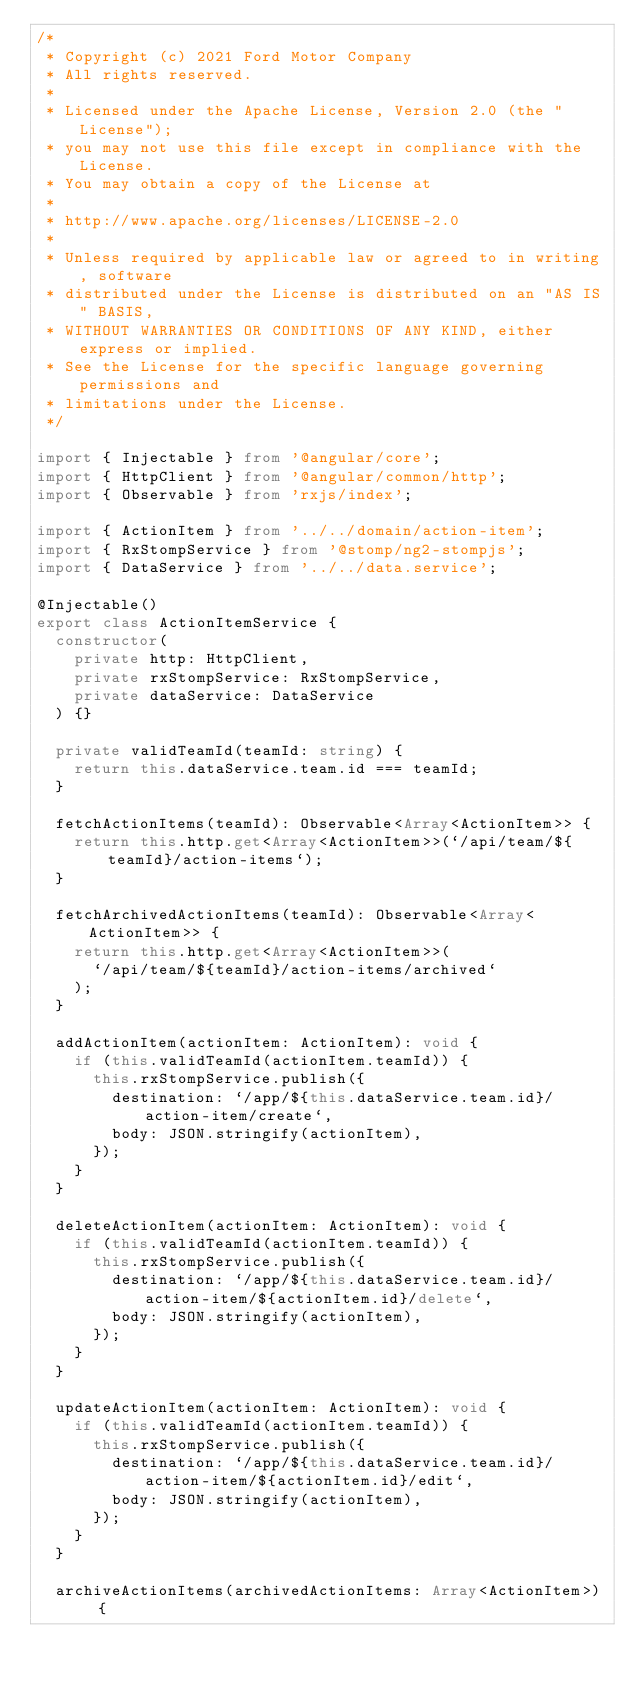<code> <loc_0><loc_0><loc_500><loc_500><_TypeScript_>/*
 * Copyright (c) 2021 Ford Motor Company
 * All rights reserved.
 *
 * Licensed under the Apache License, Version 2.0 (the "License");
 * you may not use this file except in compliance with the License.
 * You may obtain a copy of the License at
 *
 * http://www.apache.org/licenses/LICENSE-2.0
 *
 * Unless required by applicable law or agreed to in writing, software
 * distributed under the License is distributed on an "AS IS" BASIS,
 * WITHOUT WARRANTIES OR CONDITIONS OF ANY KIND, either express or implied.
 * See the License for the specific language governing permissions and
 * limitations under the License.
 */

import { Injectable } from '@angular/core';
import { HttpClient } from '@angular/common/http';
import { Observable } from 'rxjs/index';

import { ActionItem } from '../../domain/action-item';
import { RxStompService } from '@stomp/ng2-stompjs';
import { DataService } from '../../data.service';

@Injectable()
export class ActionItemService {
  constructor(
    private http: HttpClient,
    private rxStompService: RxStompService,
    private dataService: DataService
  ) {}

  private validTeamId(teamId: string) {
    return this.dataService.team.id === teamId;
  }

  fetchActionItems(teamId): Observable<Array<ActionItem>> {
    return this.http.get<Array<ActionItem>>(`/api/team/${teamId}/action-items`);
  }

  fetchArchivedActionItems(teamId): Observable<Array<ActionItem>> {
    return this.http.get<Array<ActionItem>>(
      `/api/team/${teamId}/action-items/archived`
    );
  }

  addActionItem(actionItem: ActionItem): void {
    if (this.validTeamId(actionItem.teamId)) {
      this.rxStompService.publish({
        destination: `/app/${this.dataService.team.id}/action-item/create`,
        body: JSON.stringify(actionItem),
      });
    }
  }

  deleteActionItem(actionItem: ActionItem): void {
    if (this.validTeamId(actionItem.teamId)) {
      this.rxStompService.publish({
        destination: `/app/${this.dataService.team.id}/action-item/${actionItem.id}/delete`,
        body: JSON.stringify(actionItem),
      });
    }
  }

  updateActionItem(actionItem: ActionItem): void {
    if (this.validTeamId(actionItem.teamId)) {
      this.rxStompService.publish({
        destination: `/app/${this.dataService.team.id}/action-item/${actionItem.id}/edit`,
        body: JSON.stringify(actionItem),
      });
    }
  }

  archiveActionItems(archivedActionItems: Array<ActionItem>) {</code> 